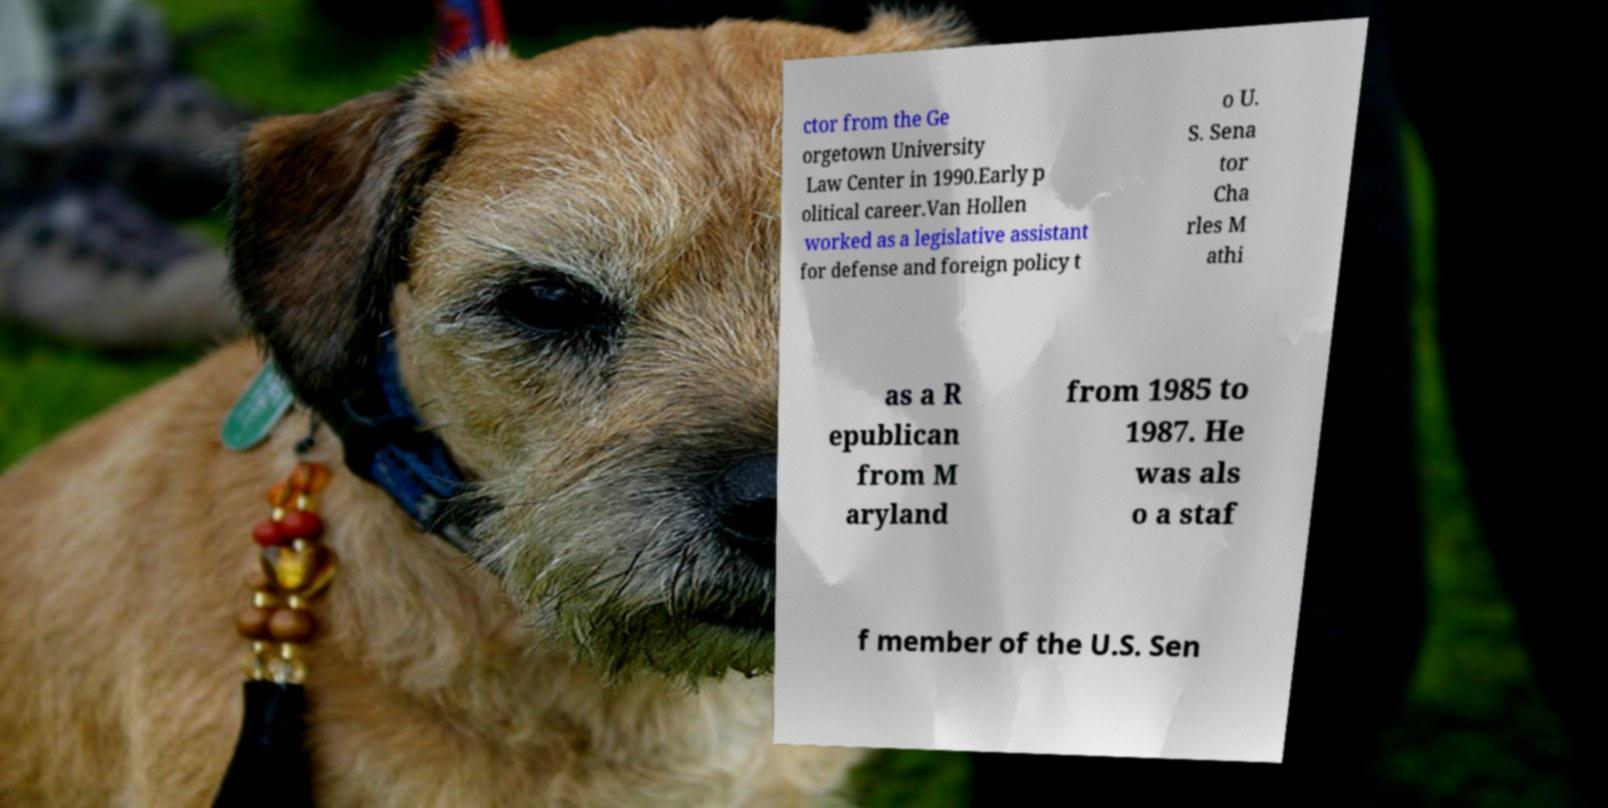Please read and relay the text visible in this image. What does it say? ctor from the Ge orgetown University Law Center in 1990.Early p olitical career.Van Hollen worked as a legislative assistant for defense and foreign policy t o U. S. Sena tor Cha rles M athi as a R epublican from M aryland from 1985 to 1987. He was als o a staf f member of the U.S. Sen 